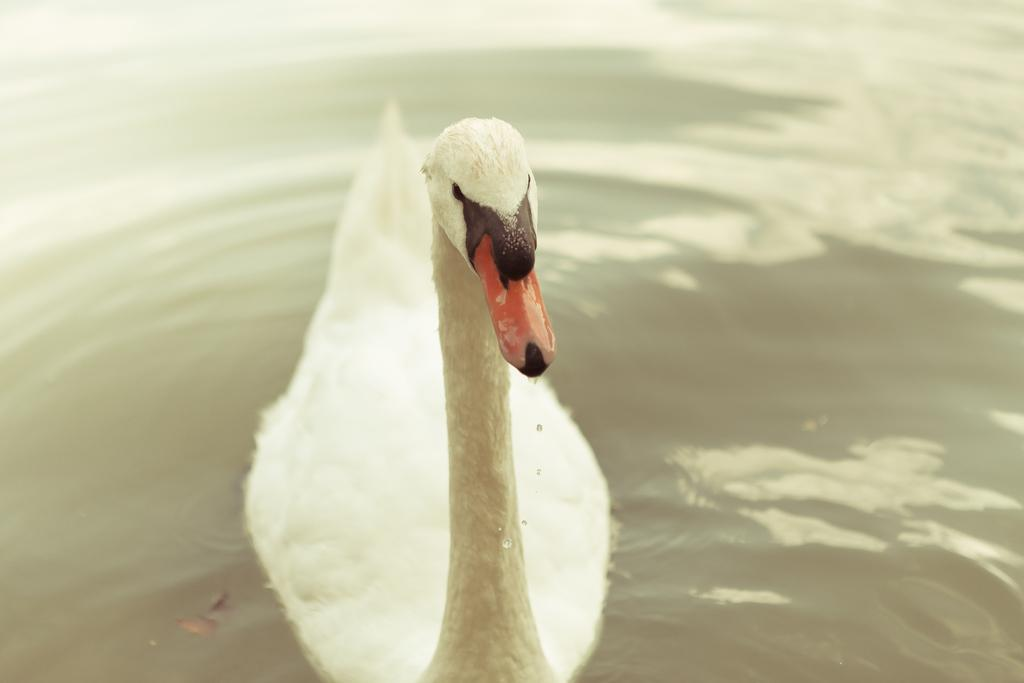What type of animal can be seen in the image? There is a bird in the water in the image. Where is the bird situated in the image? The bird is in the water in the image. What type of idea can be seen hanging from the icicle in the image? There is no icicle or idea present in the image, as it features a bird in the water. 